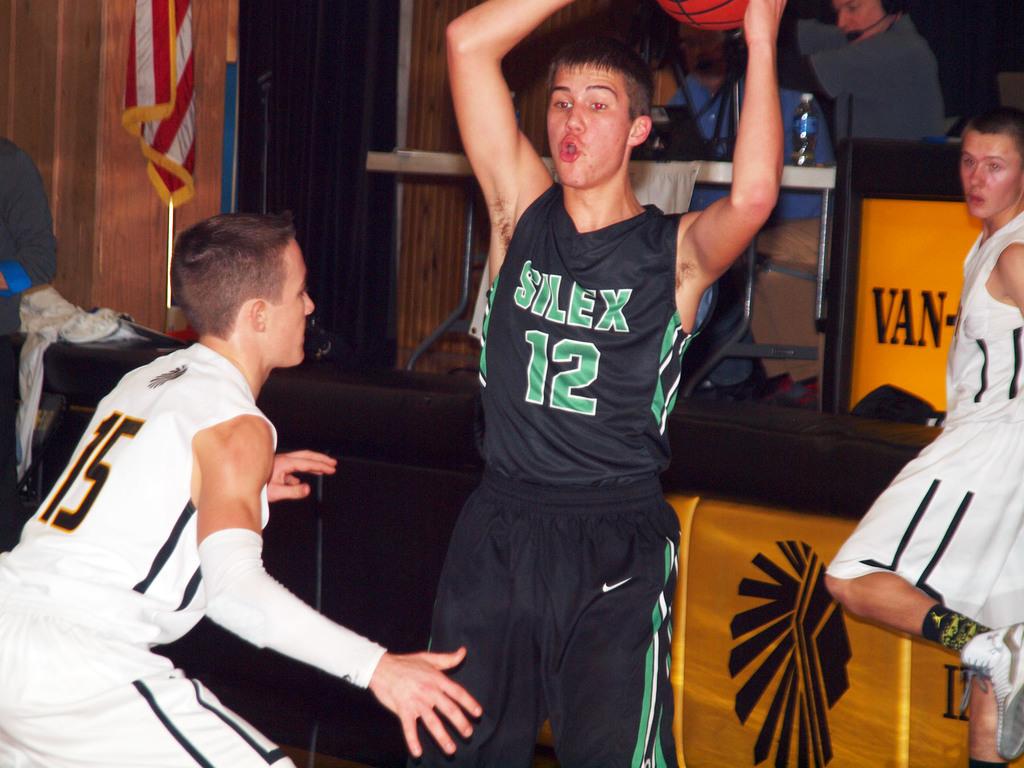What number is on the white jersey?
Make the answer very short. 15. 